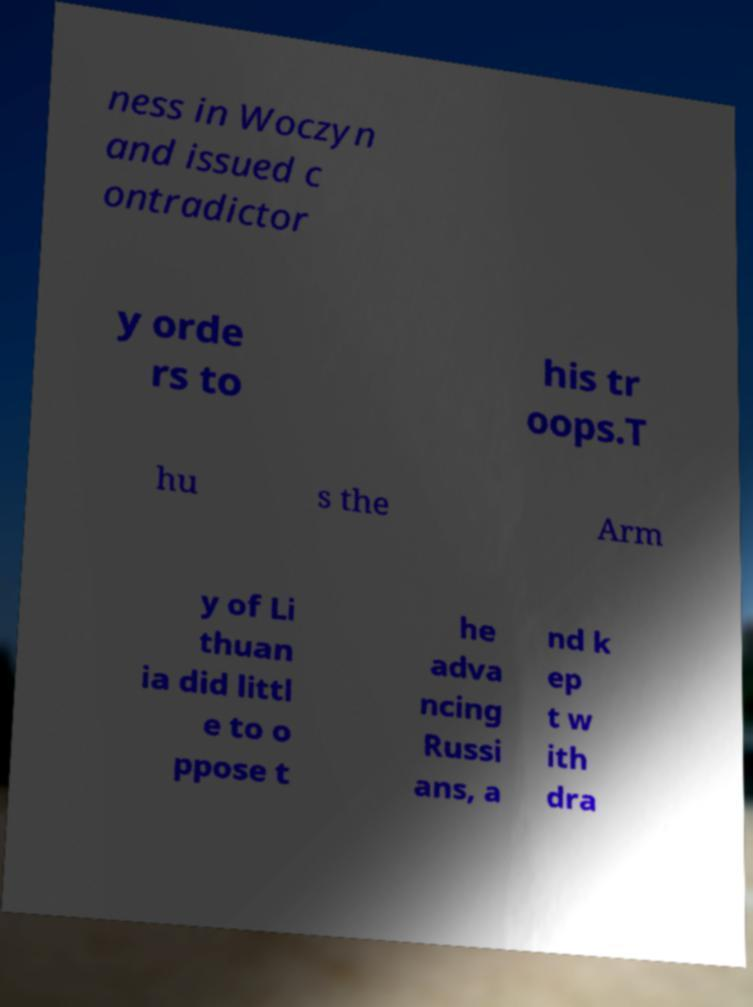Please identify and transcribe the text found in this image. ness in Woczyn and issued c ontradictor y orde rs to his tr oops.T hu s the Arm y of Li thuan ia did littl e to o ppose t he adva ncing Russi ans, a nd k ep t w ith dra 